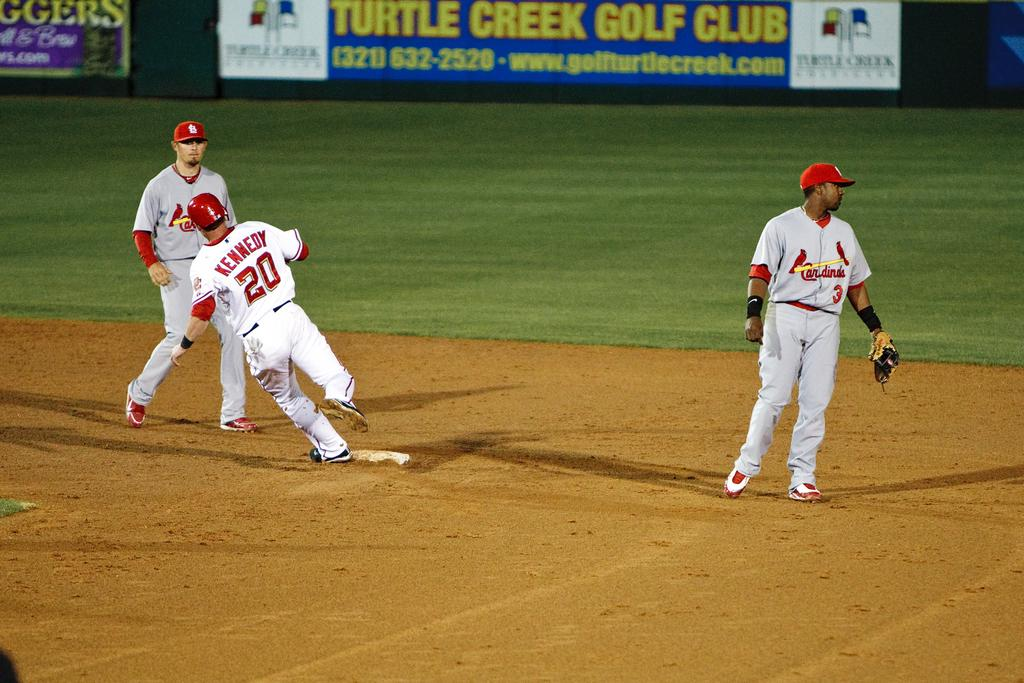<image>
Provide a brief description of the given image. Baseball player named Kennedy running to the base. 